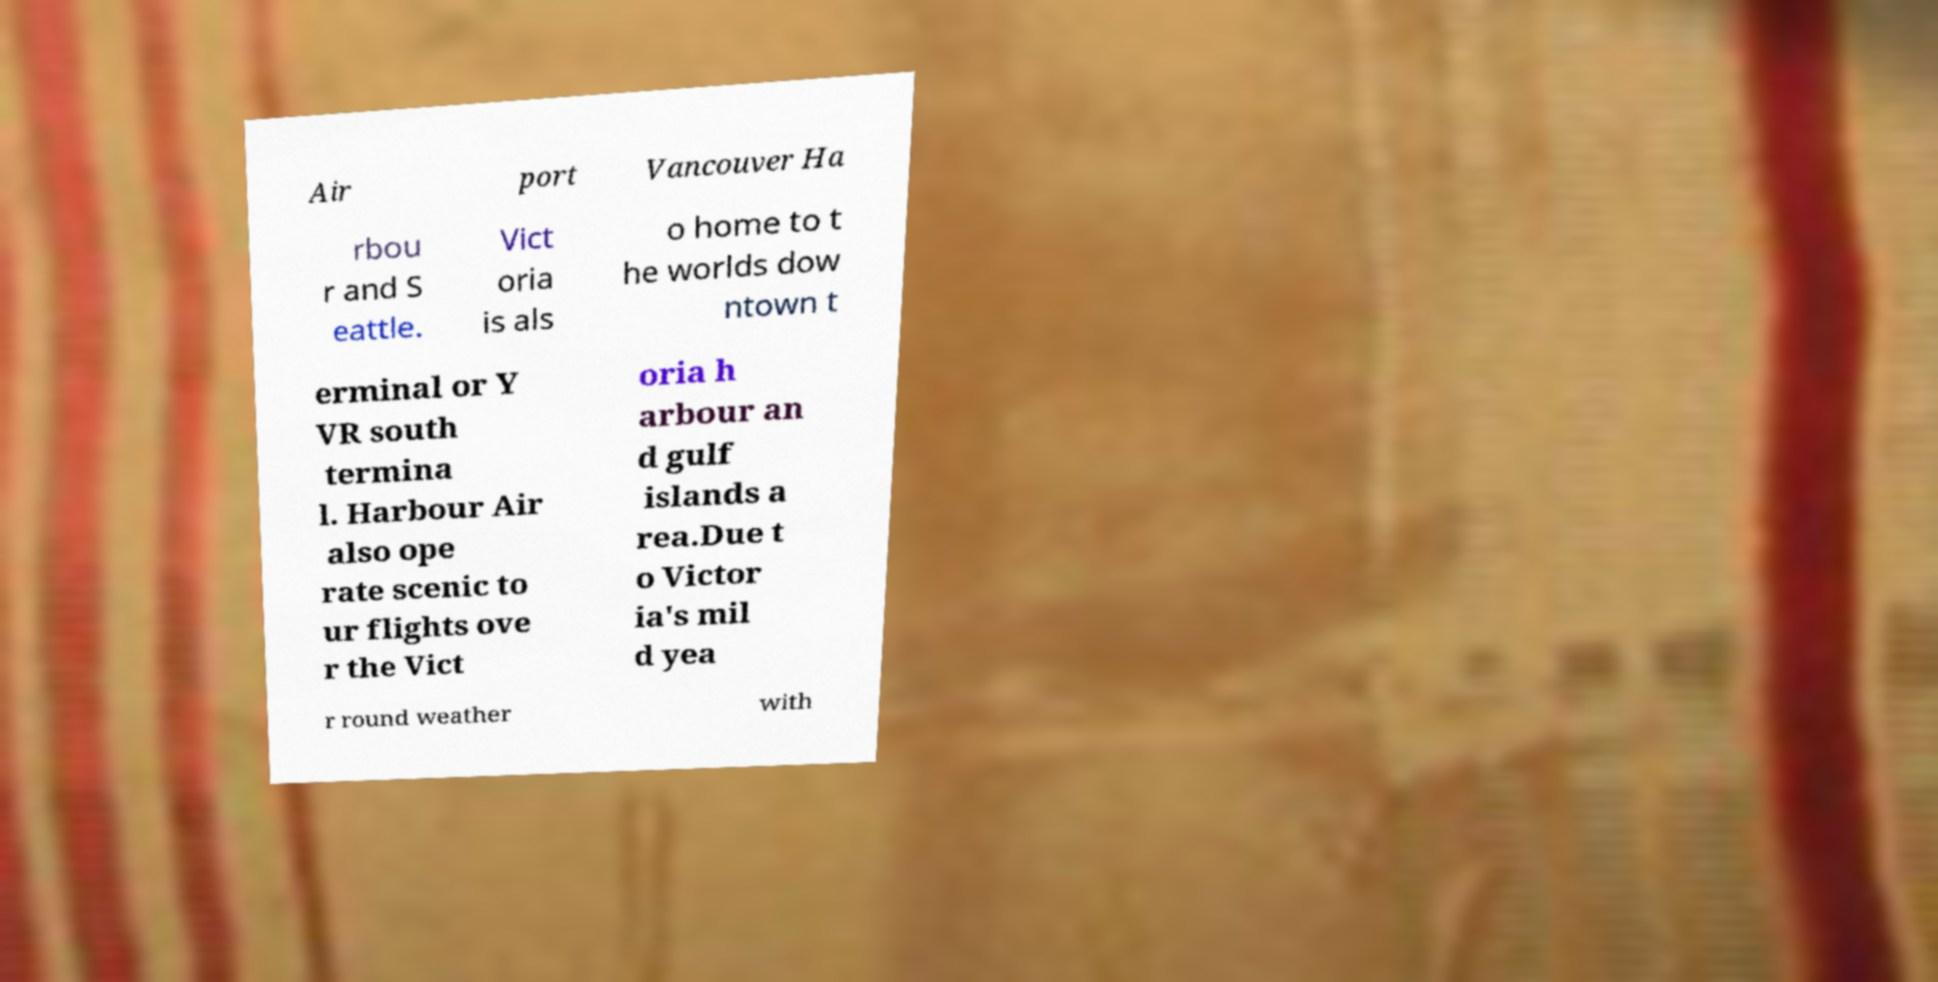Could you extract and type out the text from this image? Air port Vancouver Ha rbou r and S eattle. Vict oria is als o home to t he worlds dow ntown t erminal or Y VR south termina l. Harbour Air also ope rate scenic to ur flights ove r the Vict oria h arbour an d gulf islands a rea.Due t o Victor ia's mil d yea r round weather with 